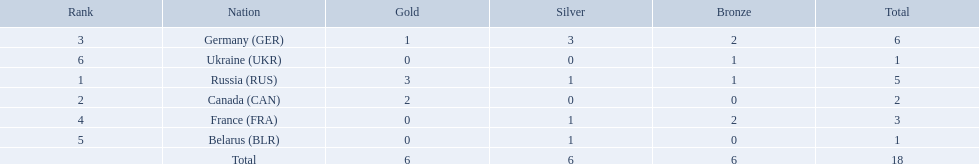Which countries had one or more gold medals? Russia (RUS), Canada (CAN), Germany (GER). Of these countries, which had at least one silver medal? Russia (RUS), Germany (GER). Of the remaining countries, who had more medals overall? Germany (GER). 